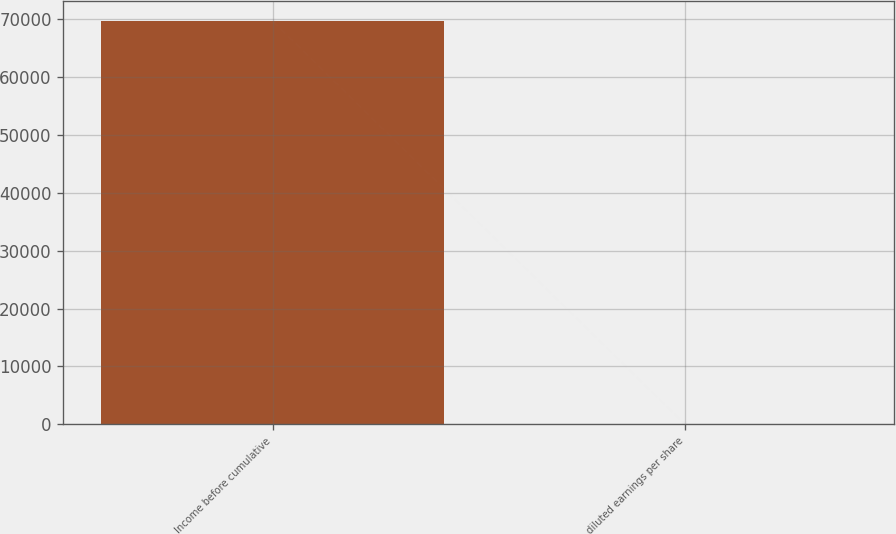Convert chart. <chart><loc_0><loc_0><loc_500><loc_500><bar_chart><fcel>Income before cumulative<fcel>diluted earnings per share<nl><fcel>69627<fcel>0.98<nl></chart> 